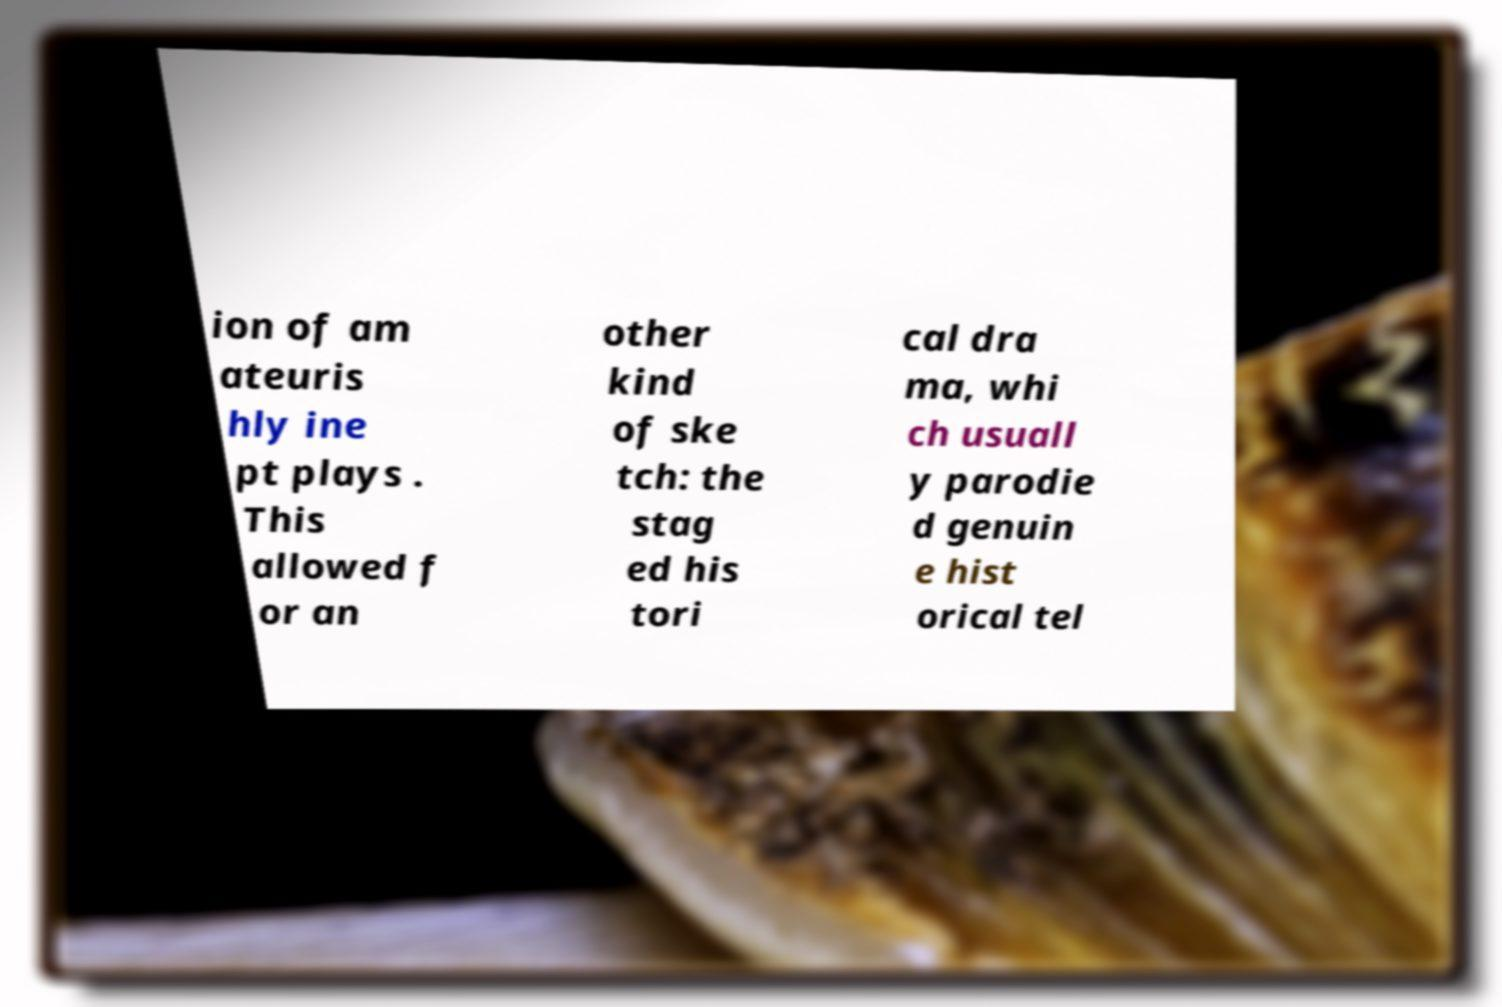There's text embedded in this image that I need extracted. Can you transcribe it verbatim? ion of am ateuris hly ine pt plays . This allowed f or an other kind of ske tch: the stag ed his tori cal dra ma, whi ch usuall y parodie d genuin e hist orical tel 